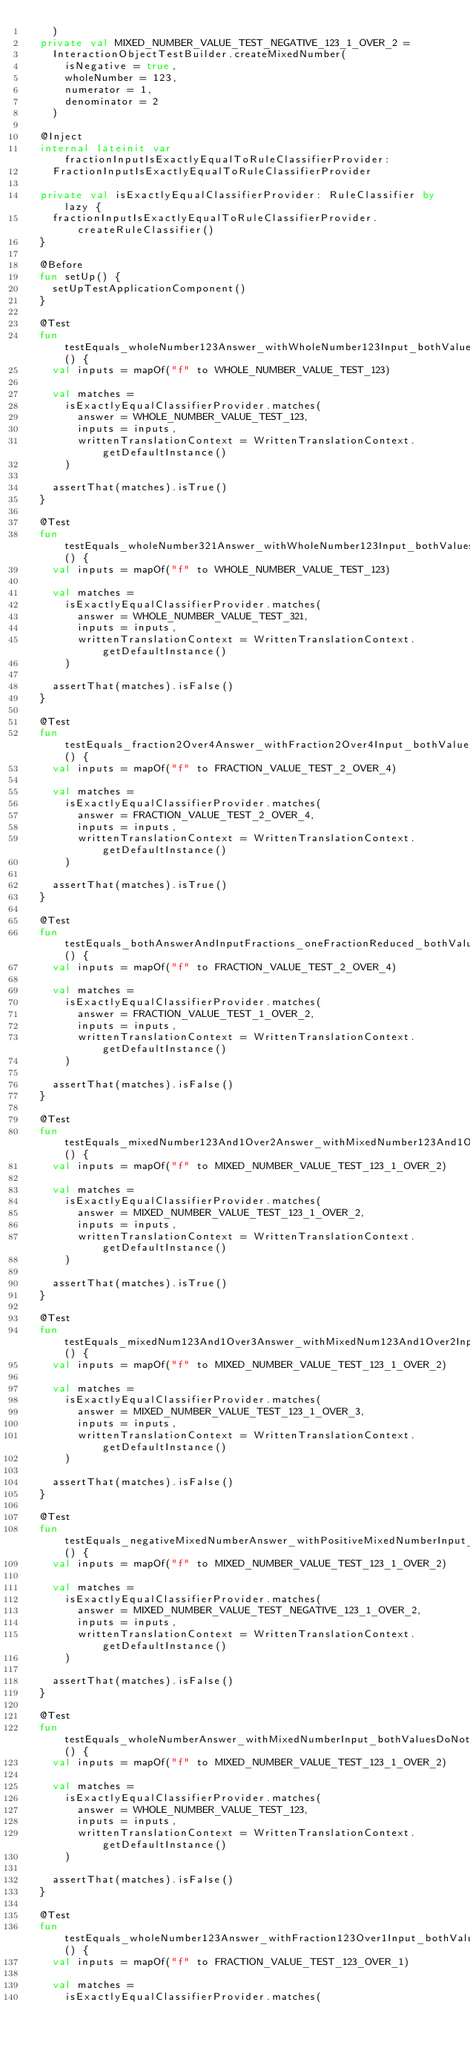Convert code to text. <code><loc_0><loc_0><loc_500><loc_500><_Kotlin_>    )
  private val MIXED_NUMBER_VALUE_TEST_NEGATIVE_123_1_OVER_2 =
    InteractionObjectTestBuilder.createMixedNumber(
      isNegative = true,
      wholeNumber = 123,
      numerator = 1,
      denominator = 2
    )

  @Inject
  internal lateinit var fractionInputIsExactlyEqualToRuleClassifierProvider:
    FractionInputIsExactlyEqualToRuleClassifierProvider

  private val isExactlyEqualClassifierProvider: RuleClassifier by lazy {
    fractionInputIsExactlyEqualToRuleClassifierProvider.createRuleClassifier()
  }

  @Before
  fun setUp() {
    setUpTestApplicationComponent()
  }

  @Test
  fun testEquals_wholeNumber123Answer_withWholeNumber123Input_bothValuesMatch() {
    val inputs = mapOf("f" to WHOLE_NUMBER_VALUE_TEST_123)

    val matches =
      isExactlyEqualClassifierProvider.matches(
        answer = WHOLE_NUMBER_VALUE_TEST_123,
        inputs = inputs,
        writtenTranslationContext = WrittenTranslationContext.getDefaultInstance()
      )

    assertThat(matches).isTrue()
  }

  @Test
  fun testEquals_wholeNumber321Answer_withWholeNumber123Input_bothValuesDoNotMatch() {
    val inputs = mapOf("f" to WHOLE_NUMBER_VALUE_TEST_123)

    val matches =
      isExactlyEqualClassifierProvider.matches(
        answer = WHOLE_NUMBER_VALUE_TEST_321,
        inputs = inputs,
        writtenTranslationContext = WrittenTranslationContext.getDefaultInstance()
      )

    assertThat(matches).isFalse()
  }

  @Test
  fun testEquals_fraction2Over4Answer_withFraction2Over4Input_bothValuesMatch() {
    val inputs = mapOf("f" to FRACTION_VALUE_TEST_2_OVER_4)

    val matches =
      isExactlyEqualClassifierProvider.matches(
        answer = FRACTION_VALUE_TEST_2_OVER_4,
        inputs = inputs,
        writtenTranslationContext = WrittenTranslationContext.getDefaultInstance()
      )

    assertThat(matches).isTrue()
  }

  @Test
  fun testEquals_bothAnswerAndInputFractions_oneFractionReduced_bothValuesDoNotMatch() {
    val inputs = mapOf("f" to FRACTION_VALUE_TEST_2_OVER_4)

    val matches =
      isExactlyEqualClassifierProvider.matches(
        answer = FRACTION_VALUE_TEST_1_OVER_2,
        inputs = inputs,
        writtenTranslationContext = WrittenTranslationContext.getDefaultInstance()
      )

    assertThat(matches).isFalse()
  }

  @Test
  fun testEquals_mixedNumber123And1Over2Answer_withMixedNumber123And1Over2Input_bothValuesMatch() {
    val inputs = mapOf("f" to MIXED_NUMBER_VALUE_TEST_123_1_OVER_2)

    val matches =
      isExactlyEqualClassifierProvider.matches(
        answer = MIXED_NUMBER_VALUE_TEST_123_1_OVER_2,
        inputs = inputs,
        writtenTranslationContext = WrittenTranslationContext.getDefaultInstance()
      )

    assertThat(matches).isTrue()
  }

  @Test
  fun testEquals_mixedNum123And1Over3Answer_withMixedNum123And1Over2Input_bothValuesDoNotMatch() {
    val inputs = mapOf("f" to MIXED_NUMBER_VALUE_TEST_123_1_OVER_2)

    val matches =
      isExactlyEqualClassifierProvider.matches(
        answer = MIXED_NUMBER_VALUE_TEST_123_1_OVER_3,
        inputs = inputs,
        writtenTranslationContext = WrittenTranslationContext.getDefaultInstance()
      )

    assertThat(matches).isFalse()
  }

  @Test
  fun testEquals_negativeMixedNumberAnswer_withPositiveMixedNumberInput_bothValuesDoNotMatch() {
    val inputs = mapOf("f" to MIXED_NUMBER_VALUE_TEST_123_1_OVER_2)

    val matches =
      isExactlyEqualClassifierProvider.matches(
        answer = MIXED_NUMBER_VALUE_TEST_NEGATIVE_123_1_OVER_2,
        inputs = inputs,
        writtenTranslationContext = WrittenTranslationContext.getDefaultInstance()
      )

    assertThat(matches).isFalse()
  }

  @Test
  fun testEquals_wholeNumberAnswer_withMixedNumberInput_bothValuesDoNotMatch() {
    val inputs = mapOf("f" to MIXED_NUMBER_VALUE_TEST_123_1_OVER_2)

    val matches =
      isExactlyEqualClassifierProvider.matches(
        answer = WHOLE_NUMBER_VALUE_TEST_123,
        inputs = inputs,
        writtenTranslationContext = WrittenTranslationContext.getDefaultInstance()
      )

    assertThat(matches).isFalse()
  }

  @Test
  fun testEquals_wholeNumber123Answer_withFraction123Over1Input_bothValuesDoNotMatch() {
    val inputs = mapOf("f" to FRACTION_VALUE_TEST_123_OVER_1)

    val matches =
      isExactlyEqualClassifierProvider.matches(</code> 